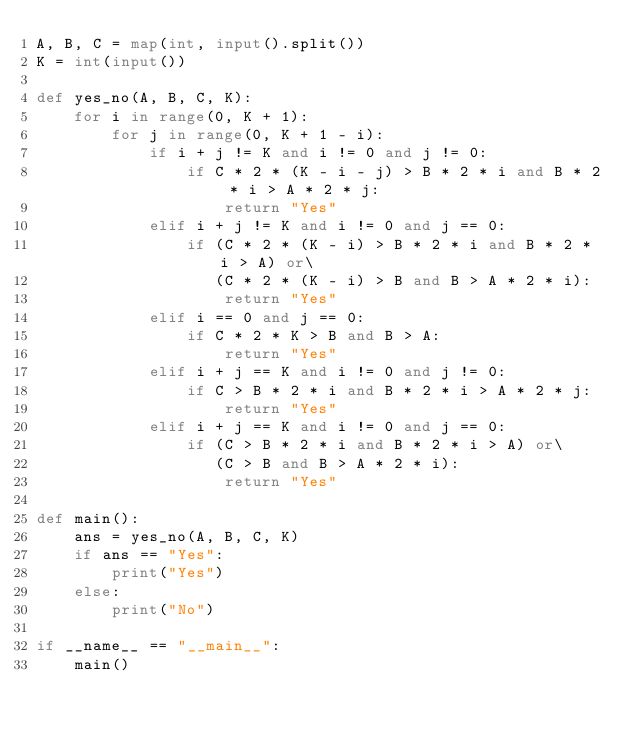Convert code to text. <code><loc_0><loc_0><loc_500><loc_500><_Python_>A, B, C = map(int, input().split())
K = int(input())

def yes_no(A, B, C, K):
    for i in range(0, K + 1):
        for j in range(0, K + 1 - i):
            if i + j != K and i != 0 and j != 0:
                if C * 2 * (K - i - j) > B * 2 * i and B * 2 * i > A * 2 * j:
                    return "Yes"
            elif i + j != K and i != 0 and j == 0:
                if (C * 2 * (K - i) > B * 2 * i and B * 2 * i > A) or\
                   (C * 2 * (K - i) > B and B > A * 2 * i):
                    return "Yes"
            elif i == 0 and j == 0:
                if C * 2 * K > B and B > A:
                    return "Yes"
            elif i + j == K and i != 0 and j != 0:
                if C > B * 2 * i and B * 2 * i > A * 2 * j:
                    return "Yes"
            elif i + j == K and i != 0 and j == 0:
                if (C > B * 2 * i and B * 2 * i > A) or\
                   (C > B and B > A * 2 * i):
                    return "Yes"

def main():
    ans = yes_no(A, B, C, K)
    if ans == "Yes":
        print("Yes")
    else:
        print("No")

if __name__ == "__main__":
    main()
        
    
</code> 